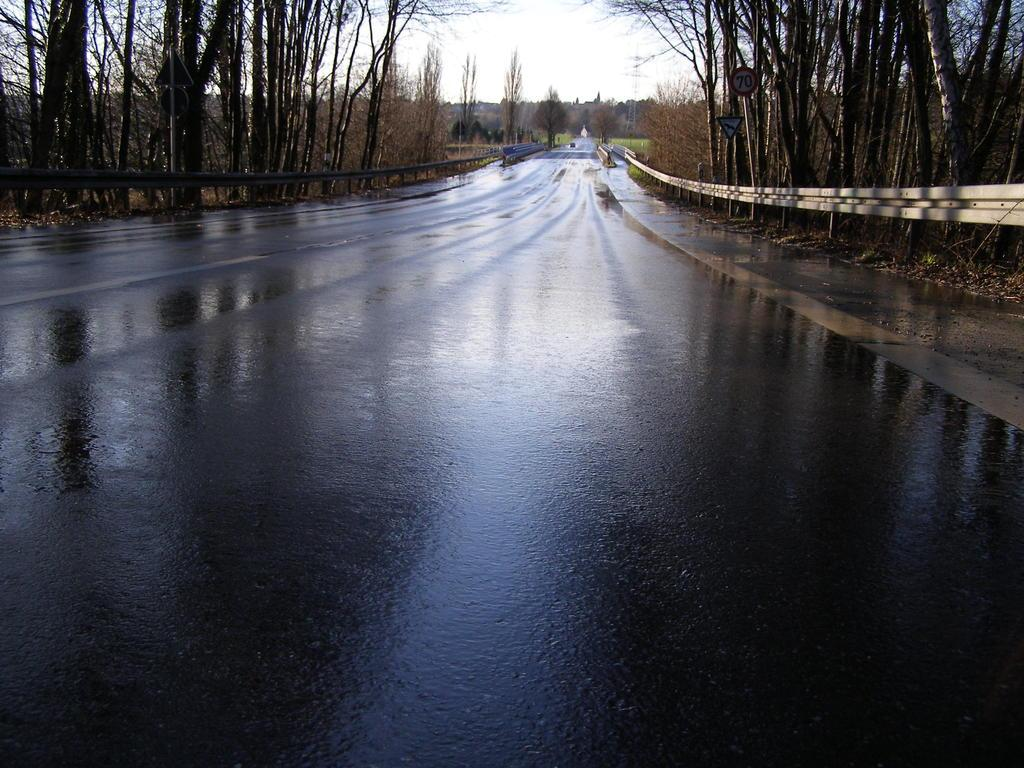What is the main feature at the center of the image? There is a road at the center of the image. What can be seen on the right side of the image? There are trees on the right side of the image. What is present on the left side of the image? There are trees on the left side of the image. Where are the sign boards located in the image? The sign boards are on the right and left side of the image. What is visible in the background of the image? The sky is visible in the background of the image. What type of notebook is being used by the trees in the image? There are no notebooks present in the image, as the main subjects are the road, trees, and sign boards. 